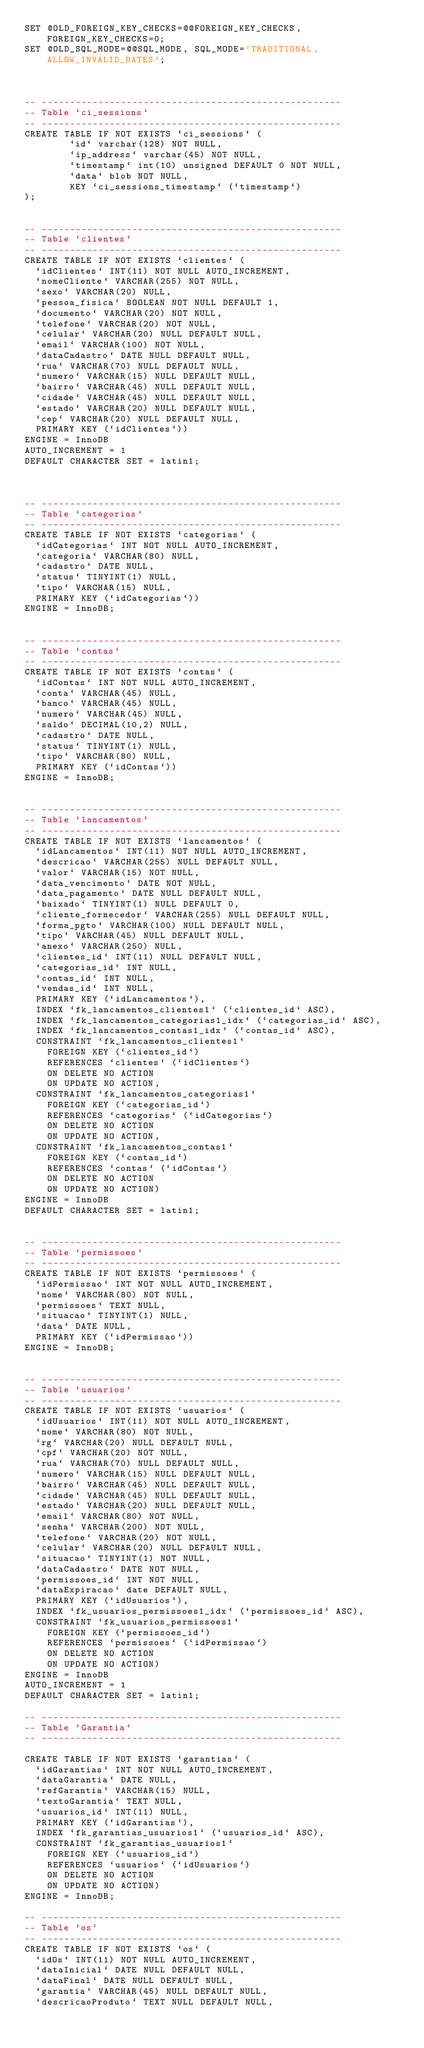<code> <loc_0><loc_0><loc_500><loc_500><_SQL_>SET @OLD_FOREIGN_KEY_CHECKS=@@FOREIGN_KEY_CHECKS, FOREIGN_KEY_CHECKS=0;
SET @OLD_SQL_MODE=@@SQL_MODE, SQL_MODE='TRADITIONAL,ALLOW_INVALID_DATES';



-- -----------------------------------------------------
-- Table `ci_sessions`
-- -----------------------------------------------------
CREATE TABLE IF NOT EXISTS `ci_sessions` (
        `id` varchar(128) NOT NULL,
        `ip_address` varchar(45) NOT NULL,
        `timestamp` int(10) unsigned DEFAULT 0 NOT NULL,
        `data` blob NOT NULL,
        KEY `ci_sessions_timestamp` (`timestamp`)
);


-- -----------------------------------------------------
-- Table `clientes`
-- -----------------------------------------------------
CREATE TABLE IF NOT EXISTS `clientes` (
  `idClientes` INT(11) NOT NULL AUTO_INCREMENT,
  `nomeCliente` VARCHAR(255) NOT NULL,
  `sexo` VARCHAR(20) NULL,
  `pessoa_fisica` BOOLEAN NOT NULL DEFAULT 1,
  `documento` VARCHAR(20) NOT NULL,
  `telefone` VARCHAR(20) NOT NULL,
  `celular` VARCHAR(20) NULL DEFAULT NULL,
  `email` VARCHAR(100) NOT NULL,
  `dataCadastro` DATE NULL DEFAULT NULL,
  `rua` VARCHAR(70) NULL DEFAULT NULL,
  `numero` VARCHAR(15) NULL DEFAULT NULL,
  `bairro` VARCHAR(45) NULL DEFAULT NULL,
  `cidade` VARCHAR(45) NULL DEFAULT NULL,
  `estado` VARCHAR(20) NULL DEFAULT NULL,
  `cep` VARCHAR(20) NULL DEFAULT NULL,
  PRIMARY KEY (`idClientes`))
ENGINE = InnoDB
AUTO_INCREMENT = 1
DEFAULT CHARACTER SET = latin1;



-- -----------------------------------------------------
-- Table `categorias`
-- -----------------------------------------------------
CREATE TABLE IF NOT EXISTS `categorias` (
  `idCategorias` INT NOT NULL AUTO_INCREMENT,
  `categoria` VARCHAR(80) NULL,
  `cadastro` DATE NULL,
  `status` TINYINT(1) NULL,
  `tipo` VARCHAR(15) NULL,
  PRIMARY KEY (`idCategorias`))
ENGINE = InnoDB;


-- -----------------------------------------------------
-- Table `contas`
-- -----------------------------------------------------
CREATE TABLE IF NOT EXISTS `contas` (
  `idContas` INT NOT NULL AUTO_INCREMENT,
  `conta` VARCHAR(45) NULL,
  `banco` VARCHAR(45) NULL,
  `numero` VARCHAR(45) NULL,
  `saldo` DECIMAL(10,2) NULL,
  `cadastro` DATE NULL,
  `status` TINYINT(1) NULL,
  `tipo` VARCHAR(80) NULL,
  PRIMARY KEY (`idContas`))
ENGINE = InnoDB;


-- -----------------------------------------------------
-- Table `lancamentos`
-- -----------------------------------------------------
CREATE TABLE IF NOT EXISTS `lancamentos` (
  `idLancamentos` INT(11) NOT NULL AUTO_INCREMENT,
  `descricao` VARCHAR(255) NULL DEFAULT NULL,
  `valor` VARCHAR(15) NOT NULL,
  `data_vencimento` DATE NOT NULL,
  `data_pagamento` DATE NULL DEFAULT NULL,
  `baixado` TINYINT(1) NULL DEFAULT 0,
  `cliente_fornecedor` VARCHAR(255) NULL DEFAULT NULL,
  `forma_pgto` VARCHAR(100) NULL DEFAULT NULL,
  `tipo` VARCHAR(45) NULL DEFAULT NULL,
  `anexo` VARCHAR(250) NULL,
  `clientes_id` INT(11) NULL DEFAULT NULL,
  `categorias_id` INT NULL,
  `contas_id` INT NULL,
  `vendas_id` INT NULL,
  PRIMARY KEY (`idLancamentos`),
  INDEX `fk_lancamentos_clientes1` (`clientes_id` ASC),
  INDEX `fk_lancamentos_categorias1_idx` (`categorias_id` ASC),
  INDEX `fk_lancamentos_contas1_idx` (`contas_id` ASC),
  CONSTRAINT `fk_lancamentos_clientes1`
    FOREIGN KEY (`clientes_id`)
    REFERENCES `clientes` (`idClientes`)
    ON DELETE NO ACTION
    ON UPDATE NO ACTION,
  CONSTRAINT `fk_lancamentos_categorias1`
    FOREIGN KEY (`categorias_id`)
    REFERENCES `categorias` (`idCategorias`)
    ON DELETE NO ACTION
    ON UPDATE NO ACTION,
  CONSTRAINT `fk_lancamentos_contas1`
    FOREIGN KEY (`contas_id`)
    REFERENCES `contas` (`idContas`)
    ON DELETE NO ACTION
    ON UPDATE NO ACTION)
ENGINE = InnoDB
DEFAULT CHARACTER SET = latin1;


-- -----------------------------------------------------
-- Table `permissoes`
-- -----------------------------------------------------
CREATE TABLE IF NOT EXISTS `permissoes` (
  `idPermissao` INT NOT NULL AUTO_INCREMENT,
  `nome` VARCHAR(80) NOT NULL,
  `permissoes` TEXT NULL,
  `situacao` TINYINT(1) NULL,
  `data` DATE NULL,
  PRIMARY KEY (`idPermissao`))
ENGINE = InnoDB;


-- -----------------------------------------------------
-- Table `usuarios`
-- -----------------------------------------------------
CREATE TABLE IF NOT EXISTS `usuarios` (
  `idUsuarios` INT(11) NOT NULL AUTO_INCREMENT,
  `nome` VARCHAR(80) NOT NULL,
  `rg` VARCHAR(20) NULL DEFAULT NULL,
  `cpf` VARCHAR(20) NOT NULL,
  `rua` VARCHAR(70) NULL DEFAULT NULL,
  `numero` VARCHAR(15) NULL DEFAULT NULL,
  `bairro` VARCHAR(45) NULL DEFAULT NULL,
  `cidade` VARCHAR(45) NULL DEFAULT NULL,
  `estado` VARCHAR(20) NULL DEFAULT NULL,
  `email` VARCHAR(80) NOT NULL,
  `senha` VARCHAR(200) NOT NULL,
  `telefone` VARCHAR(20) NOT NULL,
  `celular` VARCHAR(20) NULL DEFAULT NULL,
  `situacao` TINYINT(1) NOT NULL,
  `dataCadastro` DATE NOT NULL,
  `permissoes_id` INT NOT NULL,
  `dataExpiracao` date DEFAULT NULL,
  PRIMARY KEY (`idUsuarios`),
  INDEX `fk_usuarios_permissoes1_idx` (`permissoes_id` ASC),
  CONSTRAINT `fk_usuarios_permissoes1`
    FOREIGN KEY (`permissoes_id`)
    REFERENCES `permissoes` (`idPermissao`)
    ON DELETE NO ACTION
    ON UPDATE NO ACTION)
ENGINE = InnoDB
AUTO_INCREMENT = 1
DEFAULT CHARACTER SET = latin1;

-- -----------------------------------------------------
-- Table `Garantia`
-- -----------------------------------------------------

CREATE TABLE IF NOT EXISTS `garantias` (
  `idGarantias` INT NOT NULL AUTO_INCREMENT,
  `dataGarantia` DATE NULL,
  `refGarantia` VARCHAR(15) NULL,
  `textoGarantia` TEXT NULL,
  `usuarios_id` INT(11) NULL,
  PRIMARY KEY (`idGarantias`),
  INDEX `fk_garantias_usuarios1` (`usuarios_id` ASC),
  CONSTRAINT `fk_garantias_usuarios1`
    FOREIGN KEY (`usuarios_id`)
    REFERENCES `usuarios` (`idUsuarios`)
    ON DELETE NO ACTION
    ON UPDATE NO ACTION)
ENGINE = InnoDB;

-- -----------------------------------------------------
-- Table `os`
-- -----------------------------------------------------
CREATE TABLE IF NOT EXISTS `os` (
  `idOs` INT(11) NOT NULL AUTO_INCREMENT,
  `dataInicial` DATE NULL DEFAULT NULL,
  `dataFinal` DATE NULL DEFAULT NULL,
  `garantia` VARCHAR(45) NULL DEFAULT NULL,
  `descricaoProduto` TEXT NULL DEFAULT NULL,</code> 